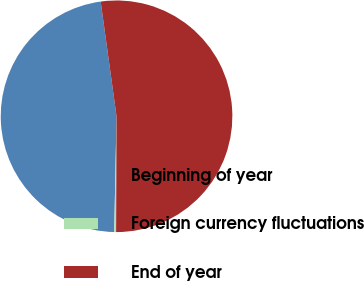<chart> <loc_0><loc_0><loc_500><loc_500><pie_chart><fcel>Beginning of year<fcel>Foreign currency fluctuations<fcel>End of year<nl><fcel>47.49%<fcel>0.26%<fcel>52.24%<nl></chart> 